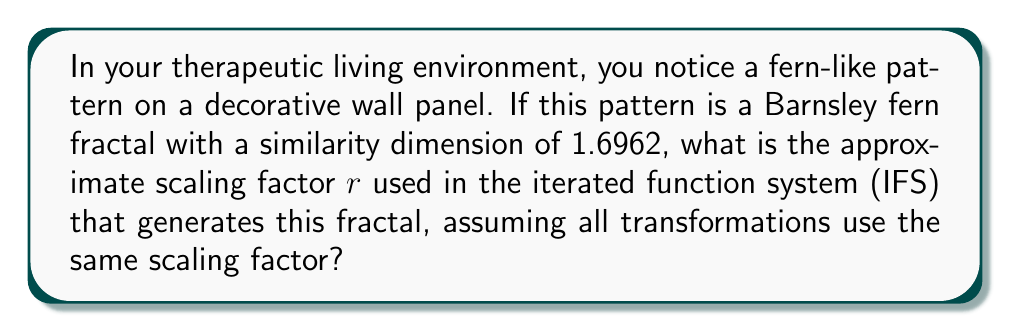Can you answer this question? To solve this problem, we'll use the relationship between the similarity dimension and the scaling factor in a self-similar fractal:

1) For a self-similar fractal, the similarity dimension $D$ is related to the number of copies $N$ and the scaling factor $r$ by the equation:

   $$N = \frac{1}{r^D}$$

2) In the case of the Barnsley fern, there are typically 4 transformations in the IFS, so $N = 4$.

3) We're given that the similarity dimension $D = 1.6962$.

4) Substituting these values into the equation:

   $$4 = \frac{1}{r^{1.6962}}$$

5) To solve for $r$, we first take both sides to the power of $-\frac{1}{1.6962}$:

   $$4^{-\frac{1}{1.6962}} = r$$

6) Using a calculator to evaluate this expression:

   $$r \approx 0.6339$$

This means that, on average, each iteration of the IFS scales the fern by a factor of about 0.6339.
Answer: $r \approx 0.6339$ 